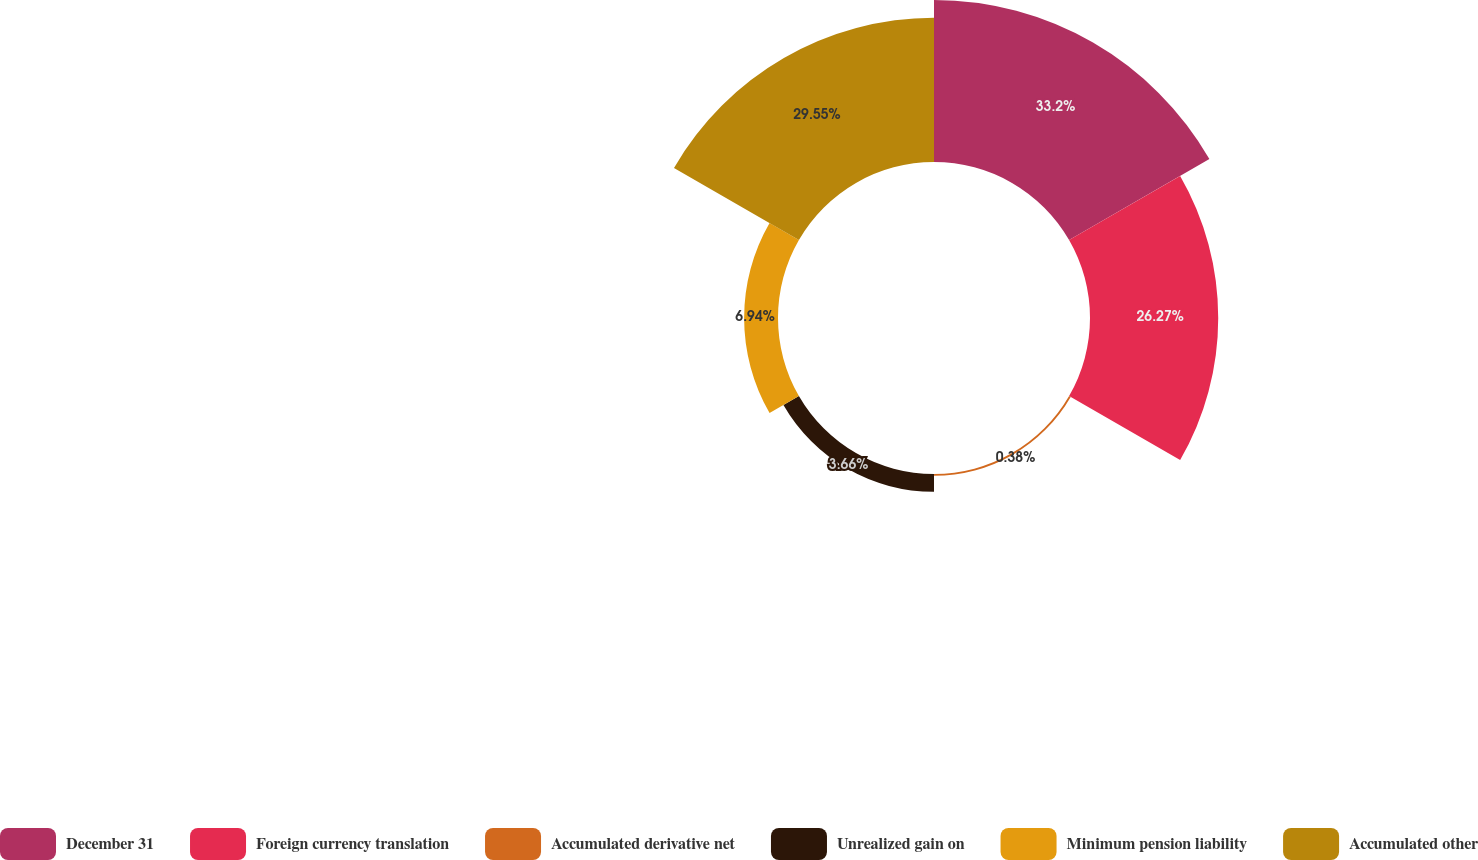Convert chart. <chart><loc_0><loc_0><loc_500><loc_500><pie_chart><fcel>December 31<fcel>Foreign currency translation<fcel>Accumulated derivative net<fcel>Unrealized gain on<fcel>Minimum pension liability<fcel>Accumulated other<nl><fcel>33.19%<fcel>26.27%<fcel>0.38%<fcel>3.66%<fcel>6.94%<fcel>29.55%<nl></chart> 